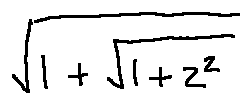<formula> <loc_0><loc_0><loc_500><loc_500>\sqrt { 1 + \sqrt { 1 + z ^ { 2 } } }</formula> 